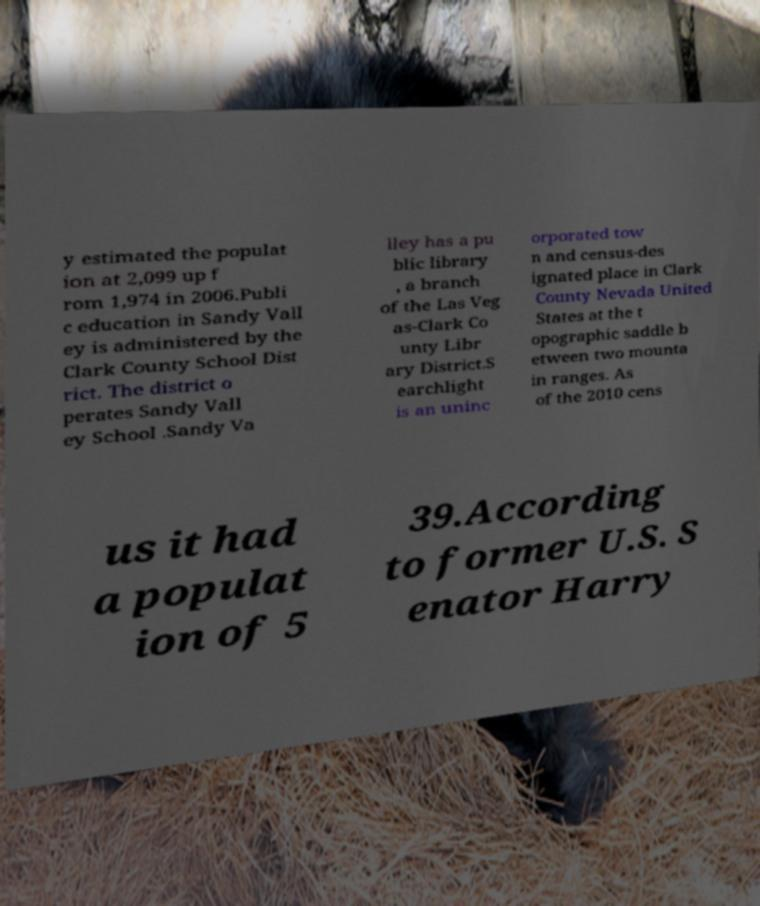Please read and relay the text visible in this image. What does it say? y estimated the populat ion at 2,099 up f rom 1,974 in 2006.Publi c education in Sandy Vall ey is administered by the Clark County School Dist rict. The district o perates Sandy Vall ey School .Sandy Va lley has a pu blic library , a branch of the Las Veg as-Clark Co unty Libr ary District.S earchlight is an uninc orporated tow n and census-des ignated place in Clark County Nevada United States at the t opographic saddle b etween two mounta in ranges. As of the 2010 cens us it had a populat ion of 5 39.According to former U.S. S enator Harry 